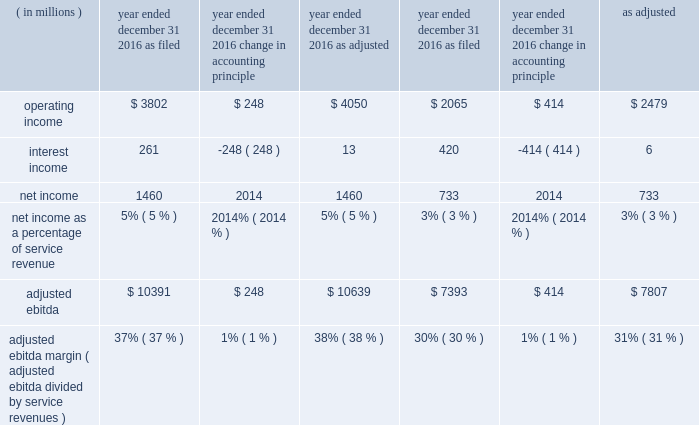Adjusted ebitda increased $ 574 million , or 5% ( 5 % ) , in 2017 primarily from : 2022 an increase in branded postpaid and prepaid service revenues primarily due to strong customer response to our un- carrier initiatives , the ongoing success of our promotional activities , and the continued strength of our metropcs brand ; 2022 higher wholesale revenues ; and 2022 higher other revenues ; partially offset by 2022 higher selling , general and administrative expenses ; 2022 lower gains on disposal of spectrum licenses of $ 600 million ; gains on disposal were $ 235 million for the year ended december 31 , 2017 , compared to $ 835 million in the same period in 2016 ; 2022 higher cost of services expense ; 2022 higher net losses on equipment ; and 2022 the negative impact from hurricanes of approximately $ 201 million , net of insurance recoveries .
Adjusted ebitda increased $ 2.8 billion , or 36% ( 36 % ) , in 2016 primarily from : 2022 increased branded postpaid and prepaid service revenues primarily due to strong customer response to our un-carrier initiatives and the ongoing success of our promotional activities ; 2022 higher gains on disposal of spectrum licenses of $ 672 million ; gains on disposal were $ 835 million in 2016 compared to $ 163 million in 2015 ; 2022 lower losses on equipment ; and 2022 focused cost control and synergies realized from the metropcs business combination , primarily in cost of services ; partially offset by 2022 higher selling , general and administrative .
Effective january 1 , 2017 , the imputed discount on eip receivables , which was previously recognized within interest income in our consolidated statements of comprehensive income , is recognized within other revenues in our consolidated statements of comprehensive income .
Due to this presentation , the imputed discount on eip receivables is included in adjusted ebitda .
See note 1 - summary of significant accounting policies of notes to the consolidated financial statements included in part ii , item 8 of this form 10-k for further information .
We have applied this change retrospectively and presented the effect on the years ended december 31 , 2016 and 2015 , in the table below. .
Adjusted ebitda margin ( adjusted ebitda divided by service revenues ) 37% ( 37 % ) 1% ( 1 % ) 38% ( 38 % ) 30% ( 30 % ) 1% ( 1 % ) 31% ( 31 % ) liquidity and capital resources our principal sources of liquidity are our cash and cash equivalents and cash generated from operations , proceeds from issuance of long-term debt and common stock , capital leases , the sale of certain receivables , financing arrangements of vendor payables which effectively extend payment terms and secured and unsecured revolving credit facilities with dt. .
How much service revenue was generated in 2016? 
Computations: (1460 / 5%)
Answer: 29200.0. 